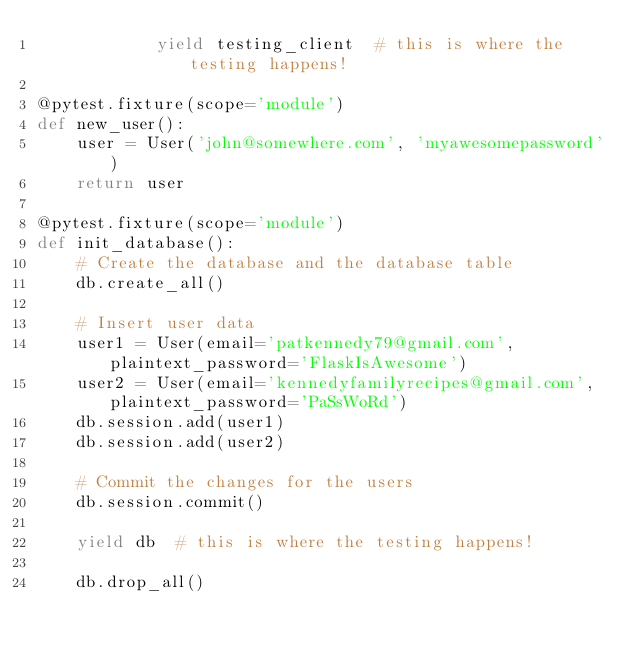<code> <loc_0><loc_0><loc_500><loc_500><_Python_>            yield testing_client  # this is where the testing happens!

@pytest.fixture(scope='module')
def new_user():
    user = User('john@somewhere.com', 'myawesomepassword')
    return user

@pytest.fixture(scope='module')
def init_database():
    # Create the database and the database table
    db.create_all()
 
    # Insert user data
    user1 = User(email='patkennedy79@gmail.com', plaintext_password='FlaskIsAwesome')
    user2 = User(email='kennedyfamilyrecipes@gmail.com', plaintext_password='PaSsWoRd')
    db.session.add(user1)
    db.session.add(user2)
 
    # Commit the changes for the users
    db.session.commit()
 
    yield db  # this is where the testing happens!
 
    db.drop_all()</code> 